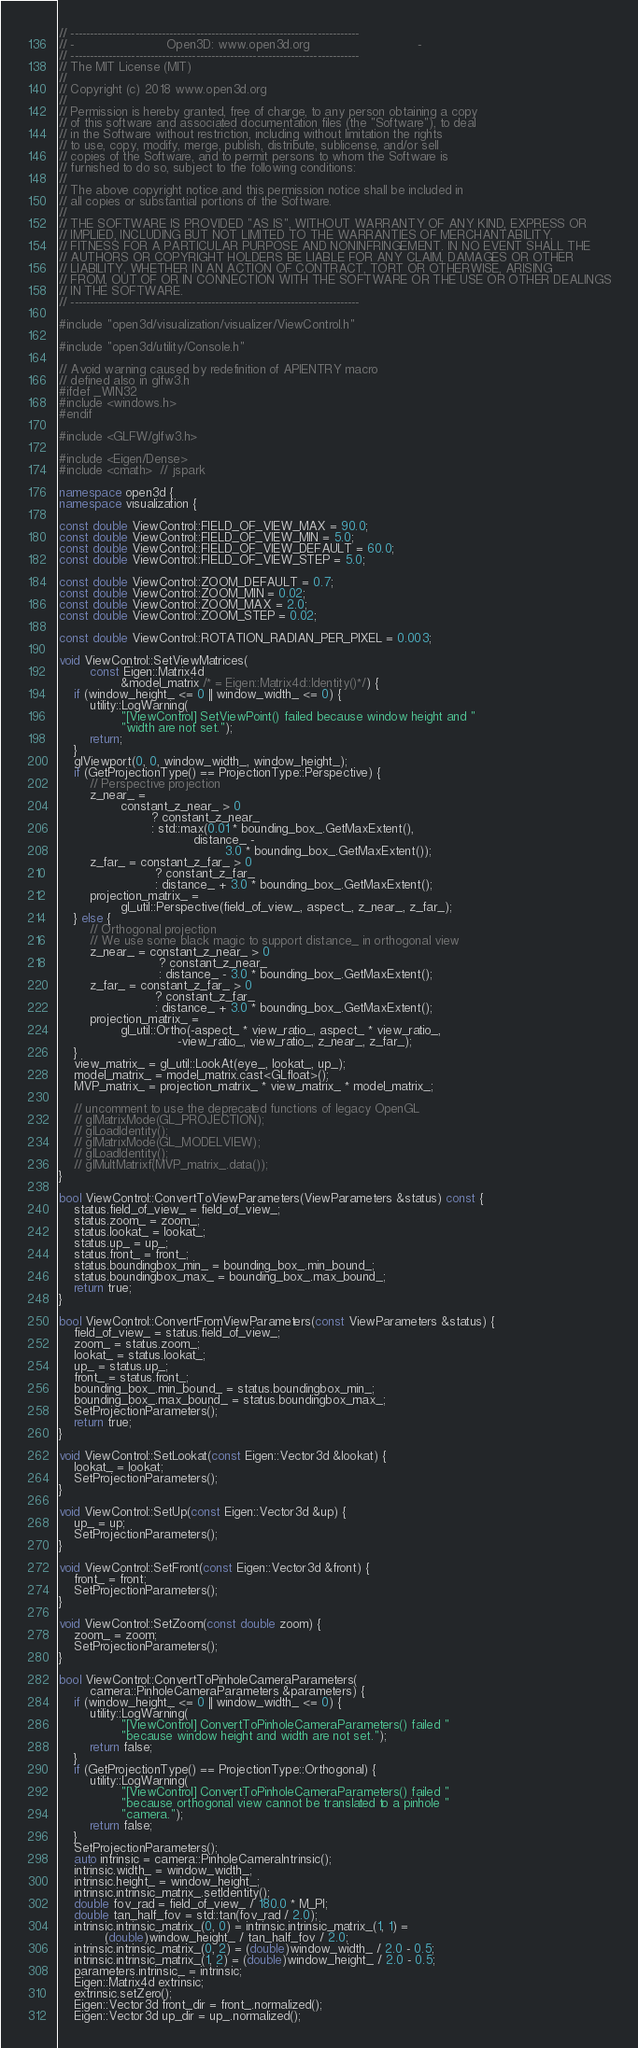Convert code to text. <code><loc_0><loc_0><loc_500><loc_500><_C++_>// ----------------------------------------------------------------------------
// -                        Open3D: www.open3d.org                            -
// ----------------------------------------------------------------------------
// The MIT License (MIT)
//
// Copyright (c) 2018 www.open3d.org
//
// Permission is hereby granted, free of charge, to any person obtaining a copy
// of this software and associated documentation files (the "Software"), to deal
// in the Software without restriction, including without limitation the rights
// to use, copy, modify, merge, publish, distribute, sublicense, and/or sell
// copies of the Software, and to permit persons to whom the Software is
// furnished to do so, subject to the following conditions:
//
// The above copyright notice and this permission notice shall be included in
// all copies or substantial portions of the Software.
//
// THE SOFTWARE IS PROVIDED "AS IS", WITHOUT WARRANTY OF ANY KIND, EXPRESS OR
// IMPLIED, INCLUDING BUT NOT LIMITED TO THE WARRANTIES OF MERCHANTABILITY,
// FITNESS FOR A PARTICULAR PURPOSE AND NONINFRINGEMENT. IN NO EVENT SHALL THE
// AUTHORS OR COPYRIGHT HOLDERS BE LIABLE FOR ANY CLAIM, DAMAGES OR OTHER
// LIABILITY, WHETHER IN AN ACTION OF CONTRACT, TORT OR OTHERWISE, ARISING
// FROM, OUT OF OR IN CONNECTION WITH THE SOFTWARE OR THE USE OR OTHER DEALINGS
// IN THE SOFTWARE.
// ----------------------------------------------------------------------------

#include "open3d/visualization/visualizer/ViewControl.h"

#include "open3d/utility/Console.h"

// Avoid warning caused by redefinition of APIENTRY macro
// defined also in glfw3.h
#ifdef _WIN32
#include <windows.h>
#endif

#include <GLFW/glfw3.h>

#include <Eigen/Dense>
#include <cmath>  // jspark

namespace open3d {
namespace visualization {

const double ViewControl::FIELD_OF_VIEW_MAX = 90.0;
const double ViewControl::FIELD_OF_VIEW_MIN = 5.0;
const double ViewControl::FIELD_OF_VIEW_DEFAULT = 60.0;
const double ViewControl::FIELD_OF_VIEW_STEP = 5.0;

const double ViewControl::ZOOM_DEFAULT = 0.7;
const double ViewControl::ZOOM_MIN = 0.02;
const double ViewControl::ZOOM_MAX = 2.0;
const double ViewControl::ZOOM_STEP = 0.02;

const double ViewControl::ROTATION_RADIAN_PER_PIXEL = 0.003;

void ViewControl::SetViewMatrices(
        const Eigen::Matrix4d
                &model_matrix /* = Eigen::Matrix4d::Identity()*/) {
    if (window_height_ <= 0 || window_width_ <= 0) {
        utility::LogWarning(
                "[ViewControl] SetViewPoint() failed because window height and "
                "width are not set.");
        return;
    }
    glViewport(0, 0, window_width_, window_height_);
    if (GetProjectionType() == ProjectionType::Perspective) {
        // Perspective projection
        z_near_ =
                constant_z_near_ > 0
                        ? constant_z_near_
                        : std::max(0.01 * bounding_box_.GetMaxExtent(),
                                   distance_ -
                                           3.0 * bounding_box_.GetMaxExtent());
        z_far_ = constant_z_far_ > 0
                         ? constant_z_far_
                         : distance_ + 3.0 * bounding_box_.GetMaxExtent();
        projection_matrix_ =
                gl_util::Perspective(field_of_view_, aspect_, z_near_, z_far_);
    } else {
        // Orthogonal projection
        // We use some black magic to support distance_ in orthogonal view
        z_near_ = constant_z_near_ > 0
                          ? constant_z_near_
                          : distance_ - 3.0 * bounding_box_.GetMaxExtent();
        z_far_ = constant_z_far_ > 0
                         ? constant_z_far_
                         : distance_ + 3.0 * bounding_box_.GetMaxExtent();
        projection_matrix_ =
                gl_util::Ortho(-aspect_ * view_ratio_, aspect_ * view_ratio_,
                               -view_ratio_, view_ratio_, z_near_, z_far_);
    }
    view_matrix_ = gl_util::LookAt(eye_, lookat_, up_);
    model_matrix_ = model_matrix.cast<GLfloat>();
    MVP_matrix_ = projection_matrix_ * view_matrix_ * model_matrix_;

    // uncomment to use the deprecated functions of legacy OpenGL
    // glMatrixMode(GL_PROJECTION);
    // glLoadIdentity();
    // glMatrixMode(GL_MODELVIEW);
    // glLoadIdentity();
    // glMultMatrixf(MVP_matrix_.data());
}

bool ViewControl::ConvertToViewParameters(ViewParameters &status) const {
    status.field_of_view_ = field_of_view_;
    status.zoom_ = zoom_;
    status.lookat_ = lookat_;
    status.up_ = up_;
    status.front_ = front_;
    status.boundingbox_min_ = bounding_box_.min_bound_;
    status.boundingbox_max_ = bounding_box_.max_bound_;
    return true;
}

bool ViewControl::ConvertFromViewParameters(const ViewParameters &status) {
    field_of_view_ = status.field_of_view_;
    zoom_ = status.zoom_;
    lookat_ = status.lookat_;
    up_ = status.up_;
    front_ = status.front_;
    bounding_box_.min_bound_ = status.boundingbox_min_;
    bounding_box_.max_bound_ = status.boundingbox_max_;
    SetProjectionParameters();
    return true;
}

void ViewControl::SetLookat(const Eigen::Vector3d &lookat) {
    lookat_ = lookat;
    SetProjectionParameters();
}

void ViewControl::SetUp(const Eigen::Vector3d &up) {
    up_ = up;
    SetProjectionParameters();
}

void ViewControl::SetFront(const Eigen::Vector3d &front) {
    front_ = front;
    SetProjectionParameters();
}

void ViewControl::SetZoom(const double zoom) {
    zoom_ = zoom;
    SetProjectionParameters();
}

bool ViewControl::ConvertToPinholeCameraParameters(
        camera::PinholeCameraParameters &parameters) {
    if (window_height_ <= 0 || window_width_ <= 0) {
        utility::LogWarning(
                "[ViewControl] ConvertToPinholeCameraParameters() failed "
                "because window height and width are not set.");
        return false;
    }
    if (GetProjectionType() == ProjectionType::Orthogonal) {
        utility::LogWarning(
                "[ViewControl] ConvertToPinholeCameraParameters() failed "
                "because orthogonal view cannot be translated to a pinhole "
                "camera.");
        return false;
    }
    SetProjectionParameters();
    auto intrinsic = camera::PinholeCameraIntrinsic();
    intrinsic.width_ = window_width_;
    intrinsic.height_ = window_height_;
    intrinsic.intrinsic_matrix_.setIdentity();
    double fov_rad = field_of_view_ / 180.0 * M_PI;
    double tan_half_fov = std::tan(fov_rad / 2.0);
    intrinsic.intrinsic_matrix_(0, 0) = intrinsic.intrinsic_matrix_(1, 1) =
            (double)window_height_ / tan_half_fov / 2.0;
    intrinsic.intrinsic_matrix_(0, 2) = (double)window_width_ / 2.0 - 0.5;
    intrinsic.intrinsic_matrix_(1, 2) = (double)window_height_ / 2.0 - 0.5;
    parameters.intrinsic_ = intrinsic;
    Eigen::Matrix4d extrinsic;
    extrinsic.setZero();
    Eigen::Vector3d front_dir = front_.normalized();
    Eigen::Vector3d up_dir = up_.normalized();</code> 